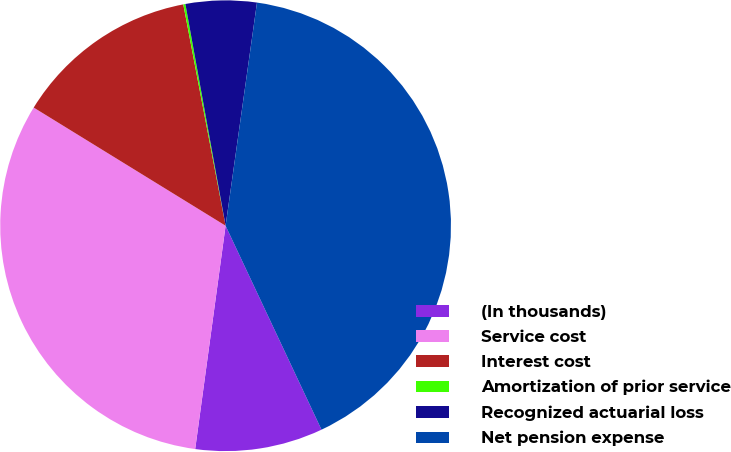<chart> <loc_0><loc_0><loc_500><loc_500><pie_chart><fcel>(In thousands)<fcel>Service cost<fcel>Interest cost<fcel>Amortization of prior service<fcel>Recognized actuarial loss<fcel>Net pension expense<nl><fcel>9.15%<fcel>31.63%<fcel>13.21%<fcel>0.15%<fcel>5.08%<fcel>40.78%<nl></chart> 